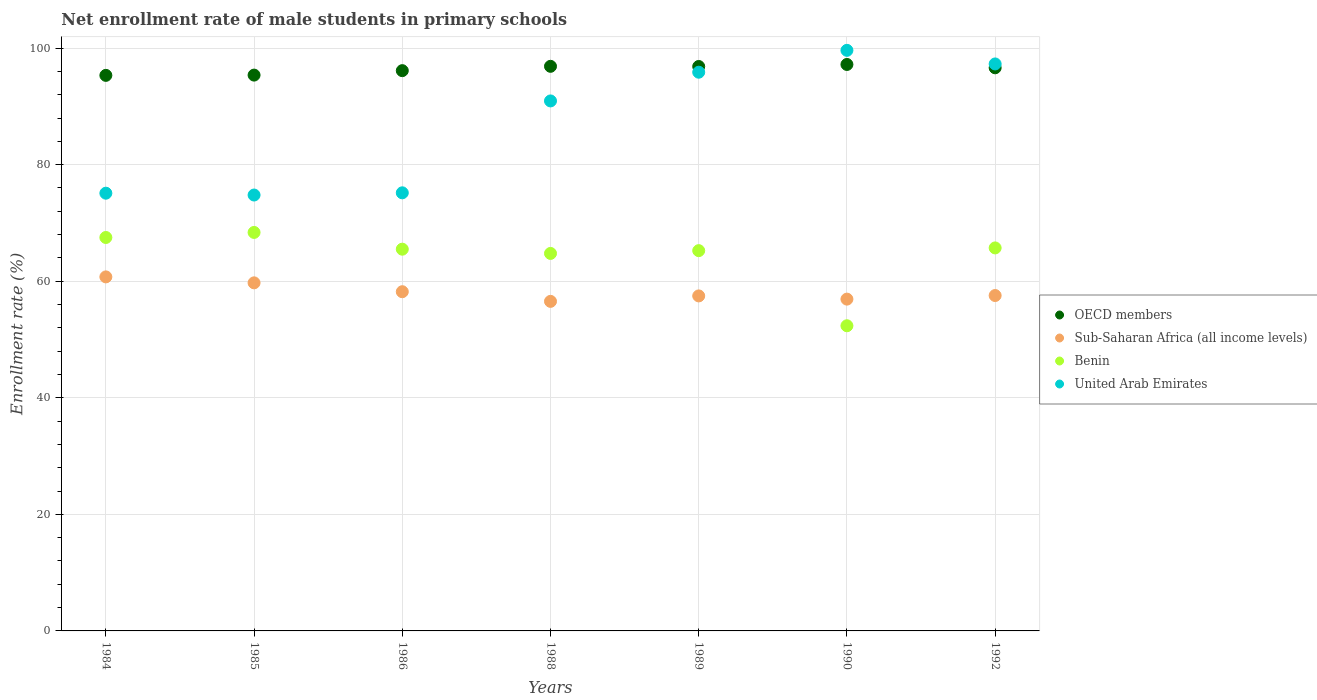What is the net enrollment rate of male students in primary schools in Benin in 1989?
Provide a short and direct response. 65.25. Across all years, what is the maximum net enrollment rate of male students in primary schools in United Arab Emirates?
Offer a very short reply. 99.62. Across all years, what is the minimum net enrollment rate of male students in primary schools in OECD members?
Give a very brief answer. 95.32. In which year was the net enrollment rate of male students in primary schools in OECD members maximum?
Give a very brief answer. 1990. What is the total net enrollment rate of male students in primary schools in OECD members in the graph?
Give a very brief answer. 674.36. What is the difference between the net enrollment rate of male students in primary schools in Benin in 1988 and that in 1992?
Ensure brevity in your answer.  -0.94. What is the difference between the net enrollment rate of male students in primary schools in OECD members in 1985 and the net enrollment rate of male students in primary schools in Sub-Saharan Africa (all income levels) in 1992?
Your answer should be very brief. 37.82. What is the average net enrollment rate of male students in primary schools in United Arab Emirates per year?
Your response must be concise. 86.97. In the year 1984, what is the difference between the net enrollment rate of male students in primary schools in Sub-Saharan Africa (all income levels) and net enrollment rate of male students in primary schools in OECD members?
Offer a terse response. -34.58. In how many years, is the net enrollment rate of male students in primary schools in OECD members greater than 40 %?
Give a very brief answer. 7. What is the ratio of the net enrollment rate of male students in primary schools in United Arab Emirates in 1984 to that in 1992?
Your answer should be very brief. 0.77. Is the net enrollment rate of male students in primary schools in OECD members in 1986 less than that in 1992?
Your response must be concise. Yes. What is the difference between the highest and the second highest net enrollment rate of male students in primary schools in United Arab Emirates?
Your answer should be compact. 2.33. What is the difference between the highest and the lowest net enrollment rate of male students in primary schools in OECD members?
Keep it short and to the point. 1.87. Is it the case that in every year, the sum of the net enrollment rate of male students in primary schools in Benin and net enrollment rate of male students in primary schools in United Arab Emirates  is greater than the sum of net enrollment rate of male students in primary schools in Sub-Saharan Africa (all income levels) and net enrollment rate of male students in primary schools in OECD members?
Make the answer very short. No. Is it the case that in every year, the sum of the net enrollment rate of male students in primary schools in OECD members and net enrollment rate of male students in primary schools in Benin  is greater than the net enrollment rate of male students in primary schools in Sub-Saharan Africa (all income levels)?
Ensure brevity in your answer.  Yes. Does the net enrollment rate of male students in primary schools in Benin monotonically increase over the years?
Your answer should be very brief. No. Is the net enrollment rate of male students in primary schools in Benin strictly greater than the net enrollment rate of male students in primary schools in OECD members over the years?
Offer a terse response. No. Is the net enrollment rate of male students in primary schools in United Arab Emirates strictly less than the net enrollment rate of male students in primary schools in Sub-Saharan Africa (all income levels) over the years?
Offer a terse response. No. How many dotlines are there?
Your answer should be very brief. 4. Where does the legend appear in the graph?
Your answer should be very brief. Center right. How many legend labels are there?
Keep it short and to the point. 4. How are the legend labels stacked?
Your answer should be compact. Vertical. What is the title of the graph?
Your answer should be very brief. Net enrollment rate of male students in primary schools. Does "Yemen, Rep." appear as one of the legend labels in the graph?
Your answer should be very brief. No. What is the label or title of the X-axis?
Provide a short and direct response. Years. What is the label or title of the Y-axis?
Give a very brief answer. Enrollment rate (%). What is the Enrollment rate (%) of OECD members in 1984?
Your response must be concise. 95.32. What is the Enrollment rate (%) of Sub-Saharan Africa (all income levels) in 1984?
Offer a very short reply. 60.74. What is the Enrollment rate (%) of Benin in 1984?
Your response must be concise. 67.51. What is the Enrollment rate (%) of United Arab Emirates in 1984?
Keep it short and to the point. 75.11. What is the Enrollment rate (%) of OECD members in 1985?
Your answer should be compact. 95.37. What is the Enrollment rate (%) of Sub-Saharan Africa (all income levels) in 1985?
Make the answer very short. 59.72. What is the Enrollment rate (%) of Benin in 1985?
Offer a terse response. 68.37. What is the Enrollment rate (%) in United Arab Emirates in 1985?
Your response must be concise. 74.79. What is the Enrollment rate (%) of OECD members in 1986?
Make the answer very short. 96.13. What is the Enrollment rate (%) in Sub-Saharan Africa (all income levels) in 1986?
Keep it short and to the point. 58.2. What is the Enrollment rate (%) in Benin in 1986?
Give a very brief answer. 65.5. What is the Enrollment rate (%) in United Arab Emirates in 1986?
Provide a succinct answer. 75.17. What is the Enrollment rate (%) of OECD members in 1988?
Your answer should be compact. 96.87. What is the Enrollment rate (%) in Sub-Saharan Africa (all income levels) in 1988?
Make the answer very short. 56.55. What is the Enrollment rate (%) in Benin in 1988?
Your answer should be very brief. 64.77. What is the Enrollment rate (%) in United Arab Emirates in 1988?
Your response must be concise. 90.94. What is the Enrollment rate (%) in OECD members in 1989?
Ensure brevity in your answer.  96.85. What is the Enrollment rate (%) in Sub-Saharan Africa (all income levels) in 1989?
Offer a very short reply. 57.48. What is the Enrollment rate (%) in Benin in 1989?
Make the answer very short. 65.25. What is the Enrollment rate (%) of United Arab Emirates in 1989?
Keep it short and to the point. 95.86. What is the Enrollment rate (%) in OECD members in 1990?
Keep it short and to the point. 97.19. What is the Enrollment rate (%) in Sub-Saharan Africa (all income levels) in 1990?
Offer a very short reply. 56.93. What is the Enrollment rate (%) in Benin in 1990?
Your response must be concise. 52.36. What is the Enrollment rate (%) of United Arab Emirates in 1990?
Offer a very short reply. 99.62. What is the Enrollment rate (%) in OECD members in 1992?
Give a very brief answer. 96.62. What is the Enrollment rate (%) of Sub-Saharan Africa (all income levels) in 1992?
Give a very brief answer. 57.55. What is the Enrollment rate (%) in Benin in 1992?
Your answer should be compact. 65.72. What is the Enrollment rate (%) in United Arab Emirates in 1992?
Provide a short and direct response. 97.28. Across all years, what is the maximum Enrollment rate (%) of OECD members?
Provide a short and direct response. 97.19. Across all years, what is the maximum Enrollment rate (%) in Sub-Saharan Africa (all income levels)?
Give a very brief answer. 60.74. Across all years, what is the maximum Enrollment rate (%) in Benin?
Make the answer very short. 68.37. Across all years, what is the maximum Enrollment rate (%) in United Arab Emirates?
Your answer should be very brief. 99.62. Across all years, what is the minimum Enrollment rate (%) in OECD members?
Your answer should be compact. 95.32. Across all years, what is the minimum Enrollment rate (%) of Sub-Saharan Africa (all income levels)?
Ensure brevity in your answer.  56.55. Across all years, what is the minimum Enrollment rate (%) of Benin?
Ensure brevity in your answer.  52.36. Across all years, what is the minimum Enrollment rate (%) in United Arab Emirates?
Your answer should be compact. 74.79. What is the total Enrollment rate (%) in OECD members in the graph?
Give a very brief answer. 674.36. What is the total Enrollment rate (%) in Sub-Saharan Africa (all income levels) in the graph?
Offer a terse response. 407.17. What is the total Enrollment rate (%) in Benin in the graph?
Give a very brief answer. 449.47. What is the total Enrollment rate (%) in United Arab Emirates in the graph?
Make the answer very short. 608.76. What is the difference between the Enrollment rate (%) of OECD members in 1984 and that in 1985?
Your response must be concise. -0.05. What is the difference between the Enrollment rate (%) in Sub-Saharan Africa (all income levels) in 1984 and that in 1985?
Provide a short and direct response. 1.02. What is the difference between the Enrollment rate (%) in Benin in 1984 and that in 1985?
Your answer should be very brief. -0.87. What is the difference between the Enrollment rate (%) in United Arab Emirates in 1984 and that in 1985?
Give a very brief answer. 0.31. What is the difference between the Enrollment rate (%) in OECD members in 1984 and that in 1986?
Your answer should be compact. -0.81. What is the difference between the Enrollment rate (%) in Sub-Saharan Africa (all income levels) in 1984 and that in 1986?
Make the answer very short. 2.54. What is the difference between the Enrollment rate (%) of Benin in 1984 and that in 1986?
Offer a very short reply. 2.01. What is the difference between the Enrollment rate (%) of United Arab Emirates in 1984 and that in 1986?
Make the answer very short. -0.07. What is the difference between the Enrollment rate (%) in OECD members in 1984 and that in 1988?
Give a very brief answer. -1.55. What is the difference between the Enrollment rate (%) of Sub-Saharan Africa (all income levels) in 1984 and that in 1988?
Your answer should be compact. 4.2. What is the difference between the Enrollment rate (%) in Benin in 1984 and that in 1988?
Ensure brevity in your answer.  2.74. What is the difference between the Enrollment rate (%) in United Arab Emirates in 1984 and that in 1988?
Offer a very short reply. -15.83. What is the difference between the Enrollment rate (%) in OECD members in 1984 and that in 1989?
Offer a terse response. -1.52. What is the difference between the Enrollment rate (%) of Sub-Saharan Africa (all income levels) in 1984 and that in 1989?
Your answer should be compact. 3.26. What is the difference between the Enrollment rate (%) of Benin in 1984 and that in 1989?
Keep it short and to the point. 2.26. What is the difference between the Enrollment rate (%) of United Arab Emirates in 1984 and that in 1989?
Your answer should be compact. -20.76. What is the difference between the Enrollment rate (%) in OECD members in 1984 and that in 1990?
Ensure brevity in your answer.  -1.87. What is the difference between the Enrollment rate (%) in Sub-Saharan Africa (all income levels) in 1984 and that in 1990?
Give a very brief answer. 3.81. What is the difference between the Enrollment rate (%) of Benin in 1984 and that in 1990?
Offer a very short reply. 15.15. What is the difference between the Enrollment rate (%) of United Arab Emirates in 1984 and that in 1990?
Keep it short and to the point. -24.51. What is the difference between the Enrollment rate (%) in OECD members in 1984 and that in 1992?
Give a very brief answer. -1.3. What is the difference between the Enrollment rate (%) in Sub-Saharan Africa (all income levels) in 1984 and that in 1992?
Make the answer very short. 3.2. What is the difference between the Enrollment rate (%) of Benin in 1984 and that in 1992?
Provide a short and direct response. 1.79. What is the difference between the Enrollment rate (%) in United Arab Emirates in 1984 and that in 1992?
Make the answer very short. -22.18. What is the difference between the Enrollment rate (%) in OECD members in 1985 and that in 1986?
Offer a terse response. -0.76. What is the difference between the Enrollment rate (%) in Sub-Saharan Africa (all income levels) in 1985 and that in 1986?
Your response must be concise. 1.52. What is the difference between the Enrollment rate (%) in Benin in 1985 and that in 1986?
Keep it short and to the point. 2.87. What is the difference between the Enrollment rate (%) in United Arab Emirates in 1985 and that in 1986?
Provide a succinct answer. -0.38. What is the difference between the Enrollment rate (%) of OECD members in 1985 and that in 1988?
Offer a terse response. -1.51. What is the difference between the Enrollment rate (%) of Sub-Saharan Africa (all income levels) in 1985 and that in 1988?
Ensure brevity in your answer.  3.18. What is the difference between the Enrollment rate (%) in Benin in 1985 and that in 1988?
Make the answer very short. 3.6. What is the difference between the Enrollment rate (%) of United Arab Emirates in 1985 and that in 1988?
Your answer should be compact. -16.14. What is the difference between the Enrollment rate (%) in OECD members in 1985 and that in 1989?
Provide a short and direct response. -1.48. What is the difference between the Enrollment rate (%) of Sub-Saharan Africa (all income levels) in 1985 and that in 1989?
Your answer should be compact. 2.24. What is the difference between the Enrollment rate (%) of Benin in 1985 and that in 1989?
Ensure brevity in your answer.  3.12. What is the difference between the Enrollment rate (%) in United Arab Emirates in 1985 and that in 1989?
Keep it short and to the point. -21.07. What is the difference between the Enrollment rate (%) of OECD members in 1985 and that in 1990?
Your answer should be very brief. -1.83. What is the difference between the Enrollment rate (%) of Sub-Saharan Africa (all income levels) in 1985 and that in 1990?
Your response must be concise. 2.79. What is the difference between the Enrollment rate (%) in Benin in 1985 and that in 1990?
Offer a terse response. 16.01. What is the difference between the Enrollment rate (%) of United Arab Emirates in 1985 and that in 1990?
Keep it short and to the point. -24.82. What is the difference between the Enrollment rate (%) of OECD members in 1985 and that in 1992?
Ensure brevity in your answer.  -1.25. What is the difference between the Enrollment rate (%) of Sub-Saharan Africa (all income levels) in 1985 and that in 1992?
Ensure brevity in your answer.  2.18. What is the difference between the Enrollment rate (%) of Benin in 1985 and that in 1992?
Make the answer very short. 2.66. What is the difference between the Enrollment rate (%) in United Arab Emirates in 1985 and that in 1992?
Your answer should be very brief. -22.49. What is the difference between the Enrollment rate (%) in OECD members in 1986 and that in 1988?
Provide a succinct answer. -0.74. What is the difference between the Enrollment rate (%) in Sub-Saharan Africa (all income levels) in 1986 and that in 1988?
Make the answer very short. 1.66. What is the difference between the Enrollment rate (%) in Benin in 1986 and that in 1988?
Provide a succinct answer. 0.73. What is the difference between the Enrollment rate (%) of United Arab Emirates in 1986 and that in 1988?
Provide a succinct answer. -15.77. What is the difference between the Enrollment rate (%) of OECD members in 1986 and that in 1989?
Your answer should be compact. -0.71. What is the difference between the Enrollment rate (%) in Sub-Saharan Africa (all income levels) in 1986 and that in 1989?
Your answer should be compact. 0.72. What is the difference between the Enrollment rate (%) of Benin in 1986 and that in 1989?
Your response must be concise. 0.25. What is the difference between the Enrollment rate (%) in United Arab Emirates in 1986 and that in 1989?
Make the answer very short. -20.69. What is the difference between the Enrollment rate (%) of OECD members in 1986 and that in 1990?
Offer a terse response. -1.06. What is the difference between the Enrollment rate (%) in Sub-Saharan Africa (all income levels) in 1986 and that in 1990?
Make the answer very short. 1.27. What is the difference between the Enrollment rate (%) of Benin in 1986 and that in 1990?
Offer a terse response. 13.14. What is the difference between the Enrollment rate (%) of United Arab Emirates in 1986 and that in 1990?
Keep it short and to the point. -24.45. What is the difference between the Enrollment rate (%) in OECD members in 1986 and that in 1992?
Keep it short and to the point. -0.49. What is the difference between the Enrollment rate (%) of Sub-Saharan Africa (all income levels) in 1986 and that in 1992?
Offer a very short reply. 0.65. What is the difference between the Enrollment rate (%) in Benin in 1986 and that in 1992?
Offer a very short reply. -0.22. What is the difference between the Enrollment rate (%) in United Arab Emirates in 1986 and that in 1992?
Offer a terse response. -22.11. What is the difference between the Enrollment rate (%) of OECD members in 1988 and that in 1989?
Your response must be concise. 0.03. What is the difference between the Enrollment rate (%) of Sub-Saharan Africa (all income levels) in 1988 and that in 1989?
Provide a succinct answer. -0.94. What is the difference between the Enrollment rate (%) of Benin in 1988 and that in 1989?
Ensure brevity in your answer.  -0.48. What is the difference between the Enrollment rate (%) of United Arab Emirates in 1988 and that in 1989?
Your answer should be compact. -4.93. What is the difference between the Enrollment rate (%) of OECD members in 1988 and that in 1990?
Offer a very short reply. -0.32. What is the difference between the Enrollment rate (%) of Sub-Saharan Africa (all income levels) in 1988 and that in 1990?
Provide a succinct answer. -0.38. What is the difference between the Enrollment rate (%) in Benin in 1988 and that in 1990?
Your answer should be very brief. 12.41. What is the difference between the Enrollment rate (%) in United Arab Emirates in 1988 and that in 1990?
Keep it short and to the point. -8.68. What is the difference between the Enrollment rate (%) of OECD members in 1988 and that in 1992?
Offer a terse response. 0.25. What is the difference between the Enrollment rate (%) of Sub-Saharan Africa (all income levels) in 1988 and that in 1992?
Your answer should be very brief. -1. What is the difference between the Enrollment rate (%) of Benin in 1988 and that in 1992?
Provide a short and direct response. -0.94. What is the difference between the Enrollment rate (%) in United Arab Emirates in 1988 and that in 1992?
Provide a succinct answer. -6.35. What is the difference between the Enrollment rate (%) in OECD members in 1989 and that in 1990?
Your answer should be very brief. -0.35. What is the difference between the Enrollment rate (%) of Sub-Saharan Africa (all income levels) in 1989 and that in 1990?
Ensure brevity in your answer.  0.55. What is the difference between the Enrollment rate (%) of Benin in 1989 and that in 1990?
Give a very brief answer. 12.89. What is the difference between the Enrollment rate (%) of United Arab Emirates in 1989 and that in 1990?
Your response must be concise. -3.75. What is the difference between the Enrollment rate (%) of OECD members in 1989 and that in 1992?
Your answer should be compact. 0.22. What is the difference between the Enrollment rate (%) of Sub-Saharan Africa (all income levels) in 1989 and that in 1992?
Your answer should be compact. -0.07. What is the difference between the Enrollment rate (%) in Benin in 1989 and that in 1992?
Your response must be concise. -0.47. What is the difference between the Enrollment rate (%) in United Arab Emirates in 1989 and that in 1992?
Offer a terse response. -1.42. What is the difference between the Enrollment rate (%) of OECD members in 1990 and that in 1992?
Give a very brief answer. 0.57. What is the difference between the Enrollment rate (%) in Sub-Saharan Africa (all income levels) in 1990 and that in 1992?
Your answer should be compact. -0.62. What is the difference between the Enrollment rate (%) of Benin in 1990 and that in 1992?
Provide a succinct answer. -13.35. What is the difference between the Enrollment rate (%) in United Arab Emirates in 1990 and that in 1992?
Your response must be concise. 2.33. What is the difference between the Enrollment rate (%) of OECD members in 1984 and the Enrollment rate (%) of Sub-Saharan Africa (all income levels) in 1985?
Provide a short and direct response. 35.6. What is the difference between the Enrollment rate (%) in OECD members in 1984 and the Enrollment rate (%) in Benin in 1985?
Keep it short and to the point. 26.95. What is the difference between the Enrollment rate (%) in OECD members in 1984 and the Enrollment rate (%) in United Arab Emirates in 1985?
Your response must be concise. 20.53. What is the difference between the Enrollment rate (%) of Sub-Saharan Africa (all income levels) in 1984 and the Enrollment rate (%) of Benin in 1985?
Offer a very short reply. -7.63. What is the difference between the Enrollment rate (%) in Sub-Saharan Africa (all income levels) in 1984 and the Enrollment rate (%) in United Arab Emirates in 1985?
Your answer should be compact. -14.05. What is the difference between the Enrollment rate (%) of Benin in 1984 and the Enrollment rate (%) of United Arab Emirates in 1985?
Ensure brevity in your answer.  -7.28. What is the difference between the Enrollment rate (%) of OECD members in 1984 and the Enrollment rate (%) of Sub-Saharan Africa (all income levels) in 1986?
Your answer should be compact. 37.12. What is the difference between the Enrollment rate (%) of OECD members in 1984 and the Enrollment rate (%) of Benin in 1986?
Keep it short and to the point. 29.82. What is the difference between the Enrollment rate (%) in OECD members in 1984 and the Enrollment rate (%) in United Arab Emirates in 1986?
Your answer should be compact. 20.15. What is the difference between the Enrollment rate (%) in Sub-Saharan Africa (all income levels) in 1984 and the Enrollment rate (%) in Benin in 1986?
Provide a short and direct response. -4.76. What is the difference between the Enrollment rate (%) of Sub-Saharan Africa (all income levels) in 1984 and the Enrollment rate (%) of United Arab Emirates in 1986?
Make the answer very short. -14.43. What is the difference between the Enrollment rate (%) of Benin in 1984 and the Enrollment rate (%) of United Arab Emirates in 1986?
Provide a short and direct response. -7.66. What is the difference between the Enrollment rate (%) in OECD members in 1984 and the Enrollment rate (%) in Sub-Saharan Africa (all income levels) in 1988?
Give a very brief answer. 38.78. What is the difference between the Enrollment rate (%) of OECD members in 1984 and the Enrollment rate (%) of Benin in 1988?
Your answer should be very brief. 30.55. What is the difference between the Enrollment rate (%) in OECD members in 1984 and the Enrollment rate (%) in United Arab Emirates in 1988?
Offer a terse response. 4.39. What is the difference between the Enrollment rate (%) in Sub-Saharan Africa (all income levels) in 1984 and the Enrollment rate (%) in Benin in 1988?
Your response must be concise. -4.03. What is the difference between the Enrollment rate (%) in Sub-Saharan Africa (all income levels) in 1984 and the Enrollment rate (%) in United Arab Emirates in 1988?
Give a very brief answer. -30.19. What is the difference between the Enrollment rate (%) of Benin in 1984 and the Enrollment rate (%) of United Arab Emirates in 1988?
Ensure brevity in your answer.  -23.43. What is the difference between the Enrollment rate (%) in OECD members in 1984 and the Enrollment rate (%) in Sub-Saharan Africa (all income levels) in 1989?
Ensure brevity in your answer.  37.84. What is the difference between the Enrollment rate (%) of OECD members in 1984 and the Enrollment rate (%) of Benin in 1989?
Keep it short and to the point. 30.07. What is the difference between the Enrollment rate (%) in OECD members in 1984 and the Enrollment rate (%) in United Arab Emirates in 1989?
Provide a short and direct response. -0.54. What is the difference between the Enrollment rate (%) of Sub-Saharan Africa (all income levels) in 1984 and the Enrollment rate (%) of Benin in 1989?
Keep it short and to the point. -4.5. What is the difference between the Enrollment rate (%) of Sub-Saharan Africa (all income levels) in 1984 and the Enrollment rate (%) of United Arab Emirates in 1989?
Your answer should be very brief. -35.12. What is the difference between the Enrollment rate (%) in Benin in 1984 and the Enrollment rate (%) in United Arab Emirates in 1989?
Offer a terse response. -28.36. What is the difference between the Enrollment rate (%) in OECD members in 1984 and the Enrollment rate (%) in Sub-Saharan Africa (all income levels) in 1990?
Offer a very short reply. 38.39. What is the difference between the Enrollment rate (%) in OECD members in 1984 and the Enrollment rate (%) in Benin in 1990?
Offer a very short reply. 42.96. What is the difference between the Enrollment rate (%) in OECD members in 1984 and the Enrollment rate (%) in United Arab Emirates in 1990?
Your answer should be compact. -4.29. What is the difference between the Enrollment rate (%) in Sub-Saharan Africa (all income levels) in 1984 and the Enrollment rate (%) in Benin in 1990?
Ensure brevity in your answer.  8.38. What is the difference between the Enrollment rate (%) in Sub-Saharan Africa (all income levels) in 1984 and the Enrollment rate (%) in United Arab Emirates in 1990?
Provide a succinct answer. -38.87. What is the difference between the Enrollment rate (%) in Benin in 1984 and the Enrollment rate (%) in United Arab Emirates in 1990?
Offer a terse response. -32.11. What is the difference between the Enrollment rate (%) in OECD members in 1984 and the Enrollment rate (%) in Sub-Saharan Africa (all income levels) in 1992?
Give a very brief answer. 37.77. What is the difference between the Enrollment rate (%) of OECD members in 1984 and the Enrollment rate (%) of Benin in 1992?
Provide a succinct answer. 29.61. What is the difference between the Enrollment rate (%) of OECD members in 1984 and the Enrollment rate (%) of United Arab Emirates in 1992?
Provide a short and direct response. -1.96. What is the difference between the Enrollment rate (%) in Sub-Saharan Africa (all income levels) in 1984 and the Enrollment rate (%) in Benin in 1992?
Provide a short and direct response. -4.97. What is the difference between the Enrollment rate (%) of Sub-Saharan Africa (all income levels) in 1984 and the Enrollment rate (%) of United Arab Emirates in 1992?
Your answer should be compact. -36.54. What is the difference between the Enrollment rate (%) of Benin in 1984 and the Enrollment rate (%) of United Arab Emirates in 1992?
Offer a terse response. -29.78. What is the difference between the Enrollment rate (%) in OECD members in 1985 and the Enrollment rate (%) in Sub-Saharan Africa (all income levels) in 1986?
Your answer should be very brief. 37.17. What is the difference between the Enrollment rate (%) in OECD members in 1985 and the Enrollment rate (%) in Benin in 1986?
Make the answer very short. 29.87. What is the difference between the Enrollment rate (%) of OECD members in 1985 and the Enrollment rate (%) of United Arab Emirates in 1986?
Provide a short and direct response. 20.2. What is the difference between the Enrollment rate (%) in Sub-Saharan Africa (all income levels) in 1985 and the Enrollment rate (%) in Benin in 1986?
Your answer should be very brief. -5.78. What is the difference between the Enrollment rate (%) in Sub-Saharan Africa (all income levels) in 1985 and the Enrollment rate (%) in United Arab Emirates in 1986?
Your response must be concise. -15.45. What is the difference between the Enrollment rate (%) in Benin in 1985 and the Enrollment rate (%) in United Arab Emirates in 1986?
Your answer should be compact. -6.8. What is the difference between the Enrollment rate (%) of OECD members in 1985 and the Enrollment rate (%) of Sub-Saharan Africa (all income levels) in 1988?
Your answer should be very brief. 38.82. What is the difference between the Enrollment rate (%) in OECD members in 1985 and the Enrollment rate (%) in Benin in 1988?
Make the answer very short. 30.6. What is the difference between the Enrollment rate (%) of OECD members in 1985 and the Enrollment rate (%) of United Arab Emirates in 1988?
Offer a very short reply. 4.43. What is the difference between the Enrollment rate (%) of Sub-Saharan Africa (all income levels) in 1985 and the Enrollment rate (%) of Benin in 1988?
Ensure brevity in your answer.  -5.05. What is the difference between the Enrollment rate (%) in Sub-Saharan Africa (all income levels) in 1985 and the Enrollment rate (%) in United Arab Emirates in 1988?
Your response must be concise. -31.21. What is the difference between the Enrollment rate (%) of Benin in 1985 and the Enrollment rate (%) of United Arab Emirates in 1988?
Make the answer very short. -22.56. What is the difference between the Enrollment rate (%) of OECD members in 1985 and the Enrollment rate (%) of Sub-Saharan Africa (all income levels) in 1989?
Keep it short and to the point. 37.89. What is the difference between the Enrollment rate (%) of OECD members in 1985 and the Enrollment rate (%) of Benin in 1989?
Your response must be concise. 30.12. What is the difference between the Enrollment rate (%) of OECD members in 1985 and the Enrollment rate (%) of United Arab Emirates in 1989?
Offer a very short reply. -0.5. What is the difference between the Enrollment rate (%) of Sub-Saharan Africa (all income levels) in 1985 and the Enrollment rate (%) of Benin in 1989?
Make the answer very short. -5.53. What is the difference between the Enrollment rate (%) of Sub-Saharan Africa (all income levels) in 1985 and the Enrollment rate (%) of United Arab Emirates in 1989?
Keep it short and to the point. -36.14. What is the difference between the Enrollment rate (%) of Benin in 1985 and the Enrollment rate (%) of United Arab Emirates in 1989?
Your answer should be compact. -27.49. What is the difference between the Enrollment rate (%) in OECD members in 1985 and the Enrollment rate (%) in Sub-Saharan Africa (all income levels) in 1990?
Make the answer very short. 38.44. What is the difference between the Enrollment rate (%) of OECD members in 1985 and the Enrollment rate (%) of Benin in 1990?
Provide a short and direct response. 43.01. What is the difference between the Enrollment rate (%) in OECD members in 1985 and the Enrollment rate (%) in United Arab Emirates in 1990?
Give a very brief answer. -4.25. What is the difference between the Enrollment rate (%) in Sub-Saharan Africa (all income levels) in 1985 and the Enrollment rate (%) in Benin in 1990?
Offer a very short reply. 7.36. What is the difference between the Enrollment rate (%) of Sub-Saharan Africa (all income levels) in 1985 and the Enrollment rate (%) of United Arab Emirates in 1990?
Offer a very short reply. -39.89. What is the difference between the Enrollment rate (%) in Benin in 1985 and the Enrollment rate (%) in United Arab Emirates in 1990?
Provide a short and direct response. -31.24. What is the difference between the Enrollment rate (%) in OECD members in 1985 and the Enrollment rate (%) in Sub-Saharan Africa (all income levels) in 1992?
Ensure brevity in your answer.  37.82. What is the difference between the Enrollment rate (%) of OECD members in 1985 and the Enrollment rate (%) of Benin in 1992?
Your answer should be very brief. 29.65. What is the difference between the Enrollment rate (%) in OECD members in 1985 and the Enrollment rate (%) in United Arab Emirates in 1992?
Your answer should be very brief. -1.91. What is the difference between the Enrollment rate (%) of Sub-Saharan Africa (all income levels) in 1985 and the Enrollment rate (%) of Benin in 1992?
Provide a short and direct response. -5.99. What is the difference between the Enrollment rate (%) in Sub-Saharan Africa (all income levels) in 1985 and the Enrollment rate (%) in United Arab Emirates in 1992?
Keep it short and to the point. -37.56. What is the difference between the Enrollment rate (%) in Benin in 1985 and the Enrollment rate (%) in United Arab Emirates in 1992?
Give a very brief answer. -28.91. What is the difference between the Enrollment rate (%) in OECD members in 1986 and the Enrollment rate (%) in Sub-Saharan Africa (all income levels) in 1988?
Offer a very short reply. 39.59. What is the difference between the Enrollment rate (%) in OECD members in 1986 and the Enrollment rate (%) in Benin in 1988?
Offer a very short reply. 31.36. What is the difference between the Enrollment rate (%) of OECD members in 1986 and the Enrollment rate (%) of United Arab Emirates in 1988?
Provide a short and direct response. 5.2. What is the difference between the Enrollment rate (%) in Sub-Saharan Africa (all income levels) in 1986 and the Enrollment rate (%) in Benin in 1988?
Offer a very short reply. -6.57. What is the difference between the Enrollment rate (%) of Sub-Saharan Africa (all income levels) in 1986 and the Enrollment rate (%) of United Arab Emirates in 1988?
Your response must be concise. -32.73. What is the difference between the Enrollment rate (%) in Benin in 1986 and the Enrollment rate (%) in United Arab Emirates in 1988?
Ensure brevity in your answer.  -25.44. What is the difference between the Enrollment rate (%) in OECD members in 1986 and the Enrollment rate (%) in Sub-Saharan Africa (all income levels) in 1989?
Offer a terse response. 38.65. What is the difference between the Enrollment rate (%) in OECD members in 1986 and the Enrollment rate (%) in Benin in 1989?
Offer a very short reply. 30.88. What is the difference between the Enrollment rate (%) of OECD members in 1986 and the Enrollment rate (%) of United Arab Emirates in 1989?
Make the answer very short. 0.27. What is the difference between the Enrollment rate (%) of Sub-Saharan Africa (all income levels) in 1986 and the Enrollment rate (%) of Benin in 1989?
Provide a succinct answer. -7.05. What is the difference between the Enrollment rate (%) of Sub-Saharan Africa (all income levels) in 1986 and the Enrollment rate (%) of United Arab Emirates in 1989?
Offer a terse response. -37.66. What is the difference between the Enrollment rate (%) in Benin in 1986 and the Enrollment rate (%) in United Arab Emirates in 1989?
Offer a terse response. -30.36. What is the difference between the Enrollment rate (%) of OECD members in 1986 and the Enrollment rate (%) of Sub-Saharan Africa (all income levels) in 1990?
Make the answer very short. 39.2. What is the difference between the Enrollment rate (%) in OECD members in 1986 and the Enrollment rate (%) in Benin in 1990?
Your response must be concise. 43.77. What is the difference between the Enrollment rate (%) in OECD members in 1986 and the Enrollment rate (%) in United Arab Emirates in 1990?
Ensure brevity in your answer.  -3.48. What is the difference between the Enrollment rate (%) in Sub-Saharan Africa (all income levels) in 1986 and the Enrollment rate (%) in Benin in 1990?
Your answer should be compact. 5.84. What is the difference between the Enrollment rate (%) of Sub-Saharan Africa (all income levels) in 1986 and the Enrollment rate (%) of United Arab Emirates in 1990?
Give a very brief answer. -41.41. What is the difference between the Enrollment rate (%) of Benin in 1986 and the Enrollment rate (%) of United Arab Emirates in 1990?
Your response must be concise. -34.12. What is the difference between the Enrollment rate (%) of OECD members in 1986 and the Enrollment rate (%) of Sub-Saharan Africa (all income levels) in 1992?
Provide a short and direct response. 38.58. What is the difference between the Enrollment rate (%) of OECD members in 1986 and the Enrollment rate (%) of Benin in 1992?
Ensure brevity in your answer.  30.42. What is the difference between the Enrollment rate (%) in OECD members in 1986 and the Enrollment rate (%) in United Arab Emirates in 1992?
Your response must be concise. -1.15. What is the difference between the Enrollment rate (%) in Sub-Saharan Africa (all income levels) in 1986 and the Enrollment rate (%) in Benin in 1992?
Provide a succinct answer. -7.51. What is the difference between the Enrollment rate (%) of Sub-Saharan Africa (all income levels) in 1986 and the Enrollment rate (%) of United Arab Emirates in 1992?
Provide a succinct answer. -39.08. What is the difference between the Enrollment rate (%) of Benin in 1986 and the Enrollment rate (%) of United Arab Emirates in 1992?
Your response must be concise. -31.78. What is the difference between the Enrollment rate (%) of OECD members in 1988 and the Enrollment rate (%) of Sub-Saharan Africa (all income levels) in 1989?
Your answer should be compact. 39.39. What is the difference between the Enrollment rate (%) in OECD members in 1988 and the Enrollment rate (%) in Benin in 1989?
Keep it short and to the point. 31.63. What is the difference between the Enrollment rate (%) in OECD members in 1988 and the Enrollment rate (%) in United Arab Emirates in 1989?
Make the answer very short. 1.01. What is the difference between the Enrollment rate (%) of Sub-Saharan Africa (all income levels) in 1988 and the Enrollment rate (%) of Benin in 1989?
Keep it short and to the point. -8.7. What is the difference between the Enrollment rate (%) in Sub-Saharan Africa (all income levels) in 1988 and the Enrollment rate (%) in United Arab Emirates in 1989?
Offer a terse response. -39.32. What is the difference between the Enrollment rate (%) in Benin in 1988 and the Enrollment rate (%) in United Arab Emirates in 1989?
Give a very brief answer. -31.09. What is the difference between the Enrollment rate (%) of OECD members in 1988 and the Enrollment rate (%) of Sub-Saharan Africa (all income levels) in 1990?
Make the answer very short. 39.94. What is the difference between the Enrollment rate (%) in OECD members in 1988 and the Enrollment rate (%) in Benin in 1990?
Your answer should be compact. 44.51. What is the difference between the Enrollment rate (%) of OECD members in 1988 and the Enrollment rate (%) of United Arab Emirates in 1990?
Make the answer very short. -2.74. What is the difference between the Enrollment rate (%) of Sub-Saharan Africa (all income levels) in 1988 and the Enrollment rate (%) of Benin in 1990?
Make the answer very short. 4.18. What is the difference between the Enrollment rate (%) in Sub-Saharan Africa (all income levels) in 1988 and the Enrollment rate (%) in United Arab Emirates in 1990?
Offer a terse response. -43.07. What is the difference between the Enrollment rate (%) in Benin in 1988 and the Enrollment rate (%) in United Arab Emirates in 1990?
Your answer should be compact. -34.84. What is the difference between the Enrollment rate (%) of OECD members in 1988 and the Enrollment rate (%) of Sub-Saharan Africa (all income levels) in 1992?
Keep it short and to the point. 39.33. What is the difference between the Enrollment rate (%) in OECD members in 1988 and the Enrollment rate (%) in Benin in 1992?
Give a very brief answer. 31.16. What is the difference between the Enrollment rate (%) in OECD members in 1988 and the Enrollment rate (%) in United Arab Emirates in 1992?
Provide a succinct answer. -0.41. What is the difference between the Enrollment rate (%) in Sub-Saharan Africa (all income levels) in 1988 and the Enrollment rate (%) in Benin in 1992?
Make the answer very short. -9.17. What is the difference between the Enrollment rate (%) of Sub-Saharan Africa (all income levels) in 1988 and the Enrollment rate (%) of United Arab Emirates in 1992?
Offer a very short reply. -40.74. What is the difference between the Enrollment rate (%) of Benin in 1988 and the Enrollment rate (%) of United Arab Emirates in 1992?
Offer a very short reply. -32.51. What is the difference between the Enrollment rate (%) of OECD members in 1989 and the Enrollment rate (%) of Sub-Saharan Africa (all income levels) in 1990?
Provide a short and direct response. 39.92. What is the difference between the Enrollment rate (%) of OECD members in 1989 and the Enrollment rate (%) of Benin in 1990?
Provide a short and direct response. 44.48. What is the difference between the Enrollment rate (%) in OECD members in 1989 and the Enrollment rate (%) in United Arab Emirates in 1990?
Make the answer very short. -2.77. What is the difference between the Enrollment rate (%) in Sub-Saharan Africa (all income levels) in 1989 and the Enrollment rate (%) in Benin in 1990?
Provide a succinct answer. 5.12. What is the difference between the Enrollment rate (%) of Sub-Saharan Africa (all income levels) in 1989 and the Enrollment rate (%) of United Arab Emirates in 1990?
Give a very brief answer. -42.13. What is the difference between the Enrollment rate (%) of Benin in 1989 and the Enrollment rate (%) of United Arab Emirates in 1990?
Offer a terse response. -34.37. What is the difference between the Enrollment rate (%) in OECD members in 1989 and the Enrollment rate (%) in Sub-Saharan Africa (all income levels) in 1992?
Offer a terse response. 39.3. What is the difference between the Enrollment rate (%) in OECD members in 1989 and the Enrollment rate (%) in Benin in 1992?
Provide a succinct answer. 31.13. What is the difference between the Enrollment rate (%) in OECD members in 1989 and the Enrollment rate (%) in United Arab Emirates in 1992?
Ensure brevity in your answer.  -0.44. What is the difference between the Enrollment rate (%) in Sub-Saharan Africa (all income levels) in 1989 and the Enrollment rate (%) in Benin in 1992?
Provide a short and direct response. -8.23. What is the difference between the Enrollment rate (%) in Sub-Saharan Africa (all income levels) in 1989 and the Enrollment rate (%) in United Arab Emirates in 1992?
Offer a terse response. -39.8. What is the difference between the Enrollment rate (%) of Benin in 1989 and the Enrollment rate (%) of United Arab Emirates in 1992?
Your answer should be very brief. -32.03. What is the difference between the Enrollment rate (%) in OECD members in 1990 and the Enrollment rate (%) in Sub-Saharan Africa (all income levels) in 1992?
Provide a succinct answer. 39.65. What is the difference between the Enrollment rate (%) of OECD members in 1990 and the Enrollment rate (%) of Benin in 1992?
Your response must be concise. 31.48. What is the difference between the Enrollment rate (%) in OECD members in 1990 and the Enrollment rate (%) in United Arab Emirates in 1992?
Make the answer very short. -0.09. What is the difference between the Enrollment rate (%) in Sub-Saharan Africa (all income levels) in 1990 and the Enrollment rate (%) in Benin in 1992?
Offer a terse response. -8.79. What is the difference between the Enrollment rate (%) of Sub-Saharan Africa (all income levels) in 1990 and the Enrollment rate (%) of United Arab Emirates in 1992?
Provide a succinct answer. -40.35. What is the difference between the Enrollment rate (%) in Benin in 1990 and the Enrollment rate (%) in United Arab Emirates in 1992?
Offer a terse response. -44.92. What is the average Enrollment rate (%) of OECD members per year?
Provide a succinct answer. 96.34. What is the average Enrollment rate (%) of Sub-Saharan Africa (all income levels) per year?
Your answer should be compact. 58.17. What is the average Enrollment rate (%) in Benin per year?
Your answer should be very brief. 64.21. What is the average Enrollment rate (%) in United Arab Emirates per year?
Ensure brevity in your answer.  86.97. In the year 1984, what is the difference between the Enrollment rate (%) of OECD members and Enrollment rate (%) of Sub-Saharan Africa (all income levels)?
Your answer should be compact. 34.58. In the year 1984, what is the difference between the Enrollment rate (%) in OECD members and Enrollment rate (%) in Benin?
Ensure brevity in your answer.  27.82. In the year 1984, what is the difference between the Enrollment rate (%) in OECD members and Enrollment rate (%) in United Arab Emirates?
Offer a terse response. 20.22. In the year 1984, what is the difference between the Enrollment rate (%) in Sub-Saharan Africa (all income levels) and Enrollment rate (%) in Benin?
Keep it short and to the point. -6.76. In the year 1984, what is the difference between the Enrollment rate (%) of Sub-Saharan Africa (all income levels) and Enrollment rate (%) of United Arab Emirates?
Your answer should be compact. -14.36. In the year 1984, what is the difference between the Enrollment rate (%) in Benin and Enrollment rate (%) in United Arab Emirates?
Keep it short and to the point. -7.6. In the year 1985, what is the difference between the Enrollment rate (%) of OECD members and Enrollment rate (%) of Sub-Saharan Africa (all income levels)?
Offer a terse response. 35.65. In the year 1985, what is the difference between the Enrollment rate (%) of OECD members and Enrollment rate (%) of Benin?
Provide a short and direct response. 27. In the year 1985, what is the difference between the Enrollment rate (%) of OECD members and Enrollment rate (%) of United Arab Emirates?
Your response must be concise. 20.58. In the year 1985, what is the difference between the Enrollment rate (%) of Sub-Saharan Africa (all income levels) and Enrollment rate (%) of Benin?
Your answer should be compact. -8.65. In the year 1985, what is the difference between the Enrollment rate (%) of Sub-Saharan Africa (all income levels) and Enrollment rate (%) of United Arab Emirates?
Provide a short and direct response. -15.07. In the year 1985, what is the difference between the Enrollment rate (%) of Benin and Enrollment rate (%) of United Arab Emirates?
Offer a very short reply. -6.42. In the year 1986, what is the difference between the Enrollment rate (%) in OECD members and Enrollment rate (%) in Sub-Saharan Africa (all income levels)?
Offer a very short reply. 37.93. In the year 1986, what is the difference between the Enrollment rate (%) of OECD members and Enrollment rate (%) of Benin?
Provide a succinct answer. 30.63. In the year 1986, what is the difference between the Enrollment rate (%) of OECD members and Enrollment rate (%) of United Arab Emirates?
Your answer should be compact. 20.96. In the year 1986, what is the difference between the Enrollment rate (%) in Sub-Saharan Africa (all income levels) and Enrollment rate (%) in Benin?
Your answer should be compact. -7.3. In the year 1986, what is the difference between the Enrollment rate (%) in Sub-Saharan Africa (all income levels) and Enrollment rate (%) in United Arab Emirates?
Give a very brief answer. -16.97. In the year 1986, what is the difference between the Enrollment rate (%) of Benin and Enrollment rate (%) of United Arab Emirates?
Give a very brief answer. -9.67. In the year 1988, what is the difference between the Enrollment rate (%) of OECD members and Enrollment rate (%) of Sub-Saharan Africa (all income levels)?
Your answer should be compact. 40.33. In the year 1988, what is the difference between the Enrollment rate (%) of OECD members and Enrollment rate (%) of Benin?
Give a very brief answer. 32.1. In the year 1988, what is the difference between the Enrollment rate (%) of OECD members and Enrollment rate (%) of United Arab Emirates?
Ensure brevity in your answer.  5.94. In the year 1988, what is the difference between the Enrollment rate (%) of Sub-Saharan Africa (all income levels) and Enrollment rate (%) of Benin?
Give a very brief answer. -8.23. In the year 1988, what is the difference between the Enrollment rate (%) in Sub-Saharan Africa (all income levels) and Enrollment rate (%) in United Arab Emirates?
Your response must be concise. -34.39. In the year 1988, what is the difference between the Enrollment rate (%) in Benin and Enrollment rate (%) in United Arab Emirates?
Ensure brevity in your answer.  -26.16. In the year 1989, what is the difference between the Enrollment rate (%) in OECD members and Enrollment rate (%) in Sub-Saharan Africa (all income levels)?
Your answer should be very brief. 39.36. In the year 1989, what is the difference between the Enrollment rate (%) of OECD members and Enrollment rate (%) of Benin?
Your answer should be compact. 31.6. In the year 1989, what is the difference between the Enrollment rate (%) of OECD members and Enrollment rate (%) of United Arab Emirates?
Provide a short and direct response. 0.98. In the year 1989, what is the difference between the Enrollment rate (%) of Sub-Saharan Africa (all income levels) and Enrollment rate (%) of Benin?
Make the answer very short. -7.77. In the year 1989, what is the difference between the Enrollment rate (%) of Sub-Saharan Africa (all income levels) and Enrollment rate (%) of United Arab Emirates?
Your answer should be very brief. -38.38. In the year 1989, what is the difference between the Enrollment rate (%) of Benin and Enrollment rate (%) of United Arab Emirates?
Offer a very short reply. -30.61. In the year 1990, what is the difference between the Enrollment rate (%) of OECD members and Enrollment rate (%) of Sub-Saharan Africa (all income levels)?
Offer a very short reply. 40.26. In the year 1990, what is the difference between the Enrollment rate (%) of OECD members and Enrollment rate (%) of Benin?
Offer a very short reply. 44.83. In the year 1990, what is the difference between the Enrollment rate (%) of OECD members and Enrollment rate (%) of United Arab Emirates?
Keep it short and to the point. -2.42. In the year 1990, what is the difference between the Enrollment rate (%) of Sub-Saharan Africa (all income levels) and Enrollment rate (%) of Benin?
Keep it short and to the point. 4.57. In the year 1990, what is the difference between the Enrollment rate (%) of Sub-Saharan Africa (all income levels) and Enrollment rate (%) of United Arab Emirates?
Ensure brevity in your answer.  -42.69. In the year 1990, what is the difference between the Enrollment rate (%) of Benin and Enrollment rate (%) of United Arab Emirates?
Offer a very short reply. -47.25. In the year 1992, what is the difference between the Enrollment rate (%) of OECD members and Enrollment rate (%) of Sub-Saharan Africa (all income levels)?
Provide a short and direct response. 39.07. In the year 1992, what is the difference between the Enrollment rate (%) of OECD members and Enrollment rate (%) of Benin?
Provide a short and direct response. 30.91. In the year 1992, what is the difference between the Enrollment rate (%) of OECD members and Enrollment rate (%) of United Arab Emirates?
Your answer should be compact. -0.66. In the year 1992, what is the difference between the Enrollment rate (%) of Sub-Saharan Africa (all income levels) and Enrollment rate (%) of Benin?
Provide a short and direct response. -8.17. In the year 1992, what is the difference between the Enrollment rate (%) of Sub-Saharan Africa (all income levels) and Enrollment rate (%) of United Arab Emirates?
Offer a terse response. -39.74. In the year 1992, what is the difference between the Enrollment rate (%) of Benin and Enrollment rate (%) of United Arab Emirates?
Make the answer very short. -31.57. What is the ratio of the Enrollment rate (%) of Sub-Saharan Africa (all income levels) in 1984 to that in 1985?
Ensure brevity in your answer.  1.02. What is the ratio of the Enrollment rate (%) in Benin in 1984 to that in 1985?
Make the answer very short. 0.99. What is the ratio of the Enrollment rate (%) of United Arab Emirates in 1984 to that in 1985?
Keep it short and to the point. 1. What is the ratio of the Enrollment rate (%) in Sub-Saharan Africa (all income levels) in 1984 to that in 1986?
Ensure brevity in your answer.  1.04. What is the ratio of the Enrollment rate (%) in Benin in 1984 to that in 1986?
Offer a very short reply. 1.03. What is the ratio of the Enrollment rate (%) of United Arab Emirates in 1984 to that in 1986?
Keep it short and to the point. 1. What is the ratio of the Enrollment rate (%) of Sub-Saharan Africa (all income levels) in 1984 to that in 1988?
Give a very brief answer. 1.07. What is the ratio of the Enrollment rate (%) of Benin in 1984 to that in 1988?
Your answer should be compact. 1.04. What is the ratio of the Enrollment rate (%) of United Arab Emirates in 1984 to that in 1988?
Make the answer very short. 0.83. What is the ratio of the Enrollment rate (%) of OECD members in 1984 to that in 1989?
Your answer should be very brief. 0.98. What is the ratio of the Enrollment rate (%) in Sub-Saharan Africa (all income levels) in 1984 to that in 1989?
Keep it short and to the point. 1.06. What is the ratio of the Enrollment rate (%) of Benin in 1984 to that in 1989?
Your response must be concise. 1.03. What is the ratio of the Enrollment rate (%) in United Arab Emirates in 1984 to that in 1989?
Offer a very short reply. 0.78. What is the ratio of the Enrollment rate (%) of OECD members in 1984 to that in 1990?
Keep it short and to the point. 0.98. What is the ratio of the Enrollment rate (%) in Sub-Saharan Africa (all income levels) in 1984 to that in 1990?
Your response must be concise. 1.07. What is the ratio of the Enrollment rate (%) in Benin in 1984 to that in 1990?
Provide a succinct answer. 1.29. What is the ratio of the Enrollment rate (%) in United Arab Emirates in 1984 to that in 1990?
Ensure brevity in your answer.  0.75. What is the ratio of the Enrollment rate (%) in OECD members in 1984 to that in 1992?
Ensure brevity in your answer.  0.99. What is the ratio of the Enrollment rate (%) of Sub-Saharan Africa (all income levels) in 1984 to that in 1992?
Keep it short and to the point. 1.06. What is the ratio of the Enrollment rate (%) of Benin in 1984 to that in 1992?
Your response must be concise. 1.03. What is the ratio of the Enrollment rate (%) in United Arab Emirates in 1984 to that in 1992?
Your answer should be very brief. 0.77. What is the ratio of the Enrollment rate (%) of OECD members in 1985 to that in 1986?
Your response must be concise. 0.99. What is the ratio of the Enrollment rate (%) in Sub-Saharan Africa (all income levels) in 1985 to that in 1986?
Provide a succinct answer. 1.03. What is the ratio of the Enrollment rate (%) in Benin in 1985 to that in 1986?
Ensure brevity in your answer.  1.04. What is the ratio of the Enrollment rate (%) of United Arab Emirates in 1985 to that in 1986?
Provide a succinct answer. 0.99. What is the ratio of the Enrollment rate (%) of OECD members in 1985 to that in 1988?
Provide a short and direct response. 0.98. What is the ratio of the Enrollment rate (%) of Sub-Saharan Africa (all income levels) in 1985 to that in 1988?
Your response must be concise. 1.06. What is the ratio of the Enrollment rate (%) of Benin in 1985 to that in 1988?
Offer a terse response. 1.06. What is the ratio of the Enrollment rate (%) of United Arab Emirates in 1985 to that in 1988?
Your answer should be compact. 0.82. What is the ratio of the Enrollment rate (%) in OECD members in 1985 to that in 1989?
Your answer should be compact. 0.98. What is the ratio of the Enrollment rate (%) in Sub-Saharan Africa (all income levels) in 1985 to that in 1989?
Provide a succinct answer. 1.04. What is the ratio of the Enrollment rate (%) of Benin in 1985 to that in 1989?
Give a very brief answer. 1.05. What is the ratio of the Enrollment rate (%) of United Arab Emirates in 1985 to that in 1989?
Your answer should be very brief. 0.78. What is the ratio of the Enrollment rate (%) of OECD members in 1985 to that in 1990?
Your answer should be very brief. 0.98. What is the ratio of the Enrollment rate (%) in Sub-Saharan Africa (all income levels) in 1985 to that in 1990?
Make the answer very short. 1.05. What is the ratio of the Enrollment rate (%) in Benin in 1985 to that in 1990?
Offer a terse response. 1.31. What is the ratio of the Enrollment rate (%) in United Arab Emirates in 1985 to that in 1990?
Offer a terse response. 0.75. What is the ratio of the Enrollment rate (%) in OECD members in 1985 to that in 1992?
Your response must be concise. 0.99. What is the ratio of the Enrollment rate (%) of Sub-Saharan Africa (all income levels) in 1985 to that in 1992?
Your answer should be very brief. 1.04. What is the ratio of the Enrollment rate (%) in Benin in 1985 to that in 1992?
Provide a succinct answer. 1.04. What is the ratio of the Enrollment rate (%) of United Arab Emirates in 1985 to that in 1992?
Your answer should be compact. 0.77. What is the ratio of the Enrollment rate (%) in Sub-Saharan Africa (all income levels) in 1986 to that in 1988?
Make the answer very short. 1.03. What is the ratio of the Enrollment rate (%) of Benin in 1986 to that in 1988?
Your answer should be very brief. 1.01. What is the ratio of the Enrollment rate (%) of United Arab Emirates in 1986 to that in 1988?
Give a very brief answer. 0.83. What is the ratio of the Enrollment rate (%) in Sub-Saharan Africa (all income levels) in 1986 to that in 1989?
Give a very brief answer. 1.01. What is the ratio of the Enrollment rate (%) in Benin in 1986 to that in 1989?
Your answer should be very brief. 1. What is the ratio of the Enrollment rate (%) in United Arab Emirates in 1986 to that in 1989?
Provide a short and direct response. 0.78. What is the ratio of the Enrollment rate (%) in OECD members in 1986 to that in 1990?
Offer a terse response. 0.99. What is the ratio of the Enrollment rate (%) in Sub-Saharan Africa (all income levels) in 1986 to that in 1990?
Your response must be concise. 1.02. What is the ratio of the Enrollment rate (%) in Benin in 1986 to that in 1990?
Give a very brief answer. 1.25. What is the ratio of the Enrollment rate (%) in United Arab Emirates in 1986 to that in 1990?
Your response must be concise. 0.75. What is the ratio of the Enrollment rate (%) of Sub-Saharan Africa (all income levels) in 1986 to that in 1992?
Offer a terse response. 1.01. What is the ratio of the Enrollment rate (%) of United Arab Emirates in 1986 to that in 1992?
Your answer should be compact. 0.77. What is the ratio of the Enrollment rate (%) in OECD members in 1988 to that in 1989?
Provide a succinct answer. 1. What is the ratio of the Enrollment rate (%) in Sub-Saharan Africa (all income levels) in 1988 to that in 1989?
Offer a terse response. 0.98. What is the ratio of the Enrollment rate (%) of United Arab Emirates in 1988 to that in 1989?
Give a very brief answer. 0.95. What is the ratio of the Enrollment rate (%) of OECD members in 1988 to that in 1990?
Keep it short and to the point. 1. What is the ratio of the Enrollment rate (%) of Sub-Saharan Africa (all income levels) in 1988 to that in 1990?
Offer a very short reply. 0.99. What is the ratio of the Enrollment rate (%) in Benin in 1988 to that in 1990?
Provide a succinct answer. 1.24. What is the ratio of the Enrollment rate (%) of United Arab Emirates in 1988 to that in 1990?
Give a very brief answer. 0.91. What is the ratio of the Enrollment rate (%) in OECD members in 1988 to that in 1992?
Your answer should be compact. 1. What is the ratio of the Enrollment rate (%) in Sub-Saharan Africa (all income levels) in 1988 to that in 1992?
Keep it short and to the point. 0.98. What is the ratio of the Enrollment rate (%) in Benin in 1988 to that in 1992?
Ensure brevity in your answer.  0.99. What is the ratio of the Enrollment rate (%) of United Arab Emirates in 1988 to that in 1992?
Give a very brief answer. 0.93. What is the ratio of the Enrollment rate (%) of Sub-Saharan Africa (all income levels) in 1989 to that in 1990?
Provide a short and direct response. 1.01. What is the ratio of the Enrollment rate (%) in Benin in 1989 to that in 1990?
Offer a terse response. 1.25. What is the ratio of the Enrollment rate (%) of United Arab Emirates in 1989 to that in 1990?
Your response must be concise. 0.96. What is the ratio of the Enrollment rate (%) in Sub-Saharan Africa (all income levels) in 1989 to that in 1992?
Provide a succinct answer. 1. What is the ratio of the Enrollment rate (%) in United Arab Emirates in 1989 to that in 1992?
Give a very brief answer. 0.99. What is the ratio of the Enrollment rate (%) of OECD members in 1990 to that in 1992?
Make the answer very short. 1.01. What is the ratio of the Enrollment rate (%) of Sub-Saharan Africa (all income levels) in 1990 to that in 1992?
Provide a short and direct response. 0.99. What is the ratio of the Enrollment rate (%) in Benin in 1990 to that in 1992?
Ensure brevity in your answer.  0.8. What is the ratio of the Enrollment rate (%) in United Arab Emirates in 1990 to that in 1992?
Provide a succinct answer. 1.02. What is the difference between the highest and the second highest Enrollment rate (%) of OECD members?
Make the answer very short. 0.32. What is the difference between the highest and the second highest Enrollment rate (%) in Sub-Saharan Africa (all income levels)?
Provide a succinct answer. 1.02. What is the difference between the highest and the second highest Enrollment rate (%) in Benin?
Offer a terse response. 0.87. What is the difference between the highest and the second highest Enrollment rate (%) in United Arab Emirates?
Offer a very short reply. 2.33. What is the difference between the highest and the lowest Enrollment rate (%) of OECD members?
Keep it short and to the point. 1.87. What is the difference between the highest and the lowest Enrollment rate (%) in Sub-Saharan Africa (all income levels)?
Your response must be concise. 4.2. What is the difference between the highest and the lowest Enrollment rate (%) in Benin?
Ensure brevity in your answer.  16.01. What is the difference between the highest and the lowest Enrollment rate (%) in United Arab Emirates?
Ensure brevity in your answer.  24.82. 